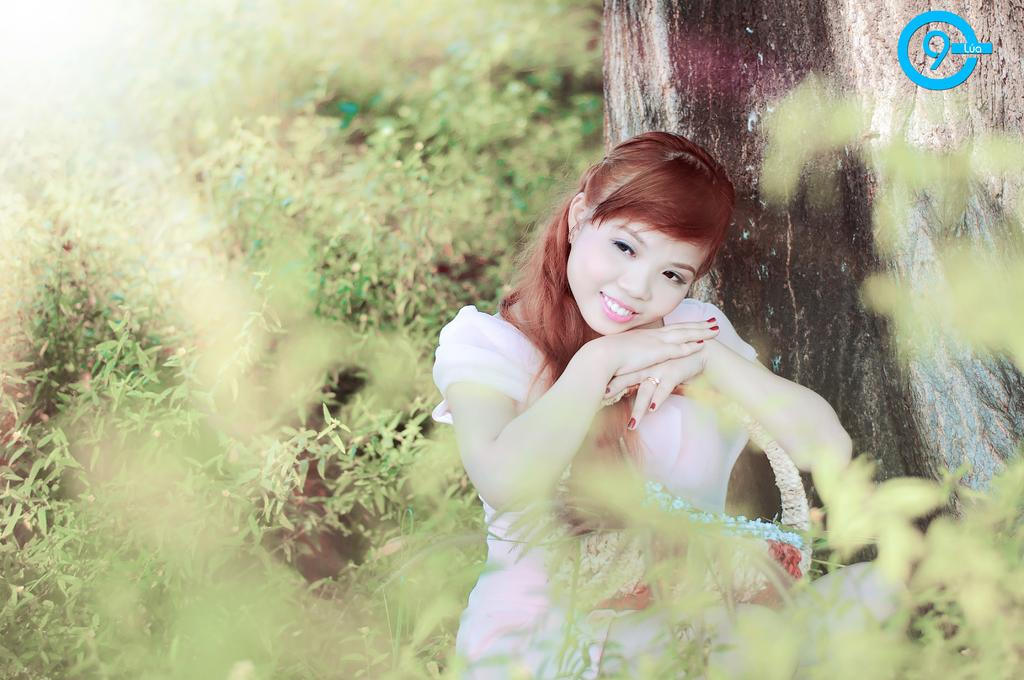Who is present in the image? There is a woman in the image. What is the woman's expression? The woman is smiling. What can be seen in the background of the image? There are plants in the background of the image. Is there any text or marking in the image? Yes, there is a watermark in the top right side of the image. What type of army is visible in the image? There is no army present in the image; it features a woman smiling with plants in the background and a watermark in the top right corner. Can you tell me what time of day the train is passing by in the image? There is no train present in the image, so it is not possible to determine the time of day based on this information. 